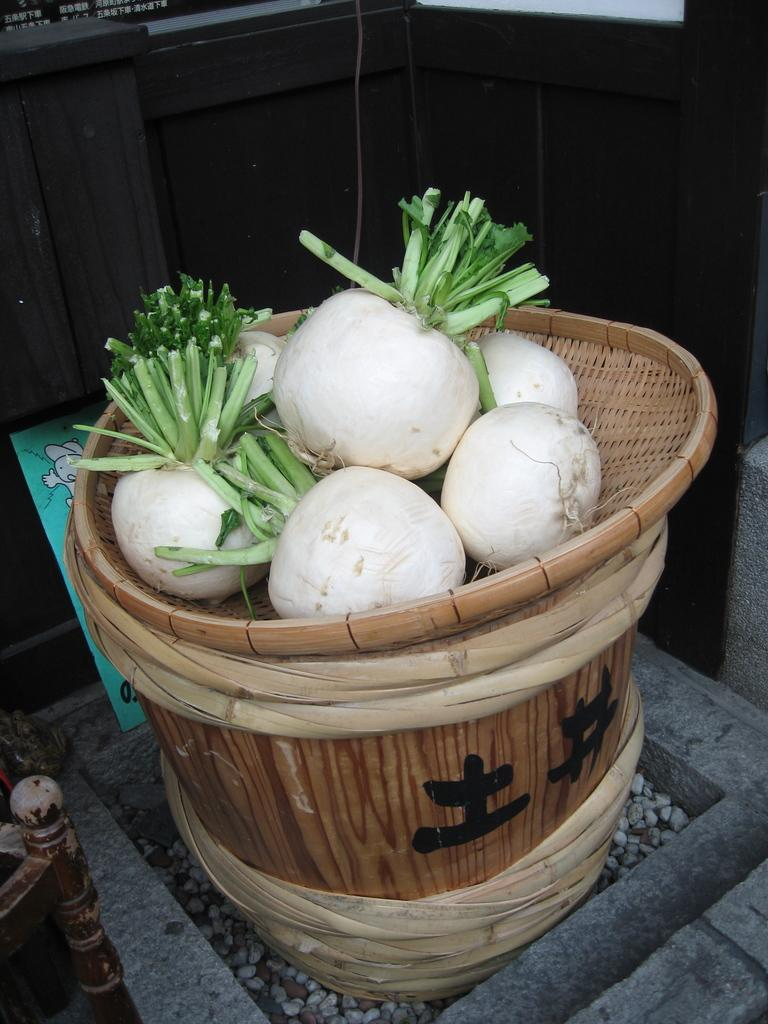What type of furniture is in the image? There is a wooden stool in the image. What is placed on the wooden stool? There is a wooden bowl on the stool. What is inside the wooden bowl? There are white onions in the bowl. What can be seen in the background of the image? There is a wooden wall in the background of the image. What type of committee is responsible for the onions in the image? There is no committee present in the image, and the onions are simply placed in a wooden bowl on a stool. Can you tell me which jewel is being used to hold the onions in the image? There are no jewels present in the image; the onions are held in a wooden bowl. 